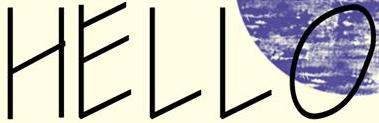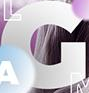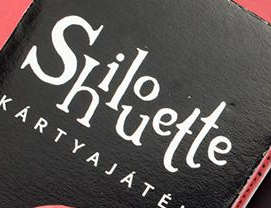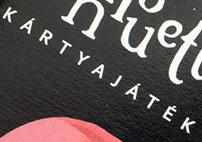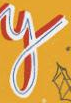What text is displayed in these images sequentially, separated by a semicolon? HELLO; G; Shilouette; KÁRTYAJÁTÉK; y 